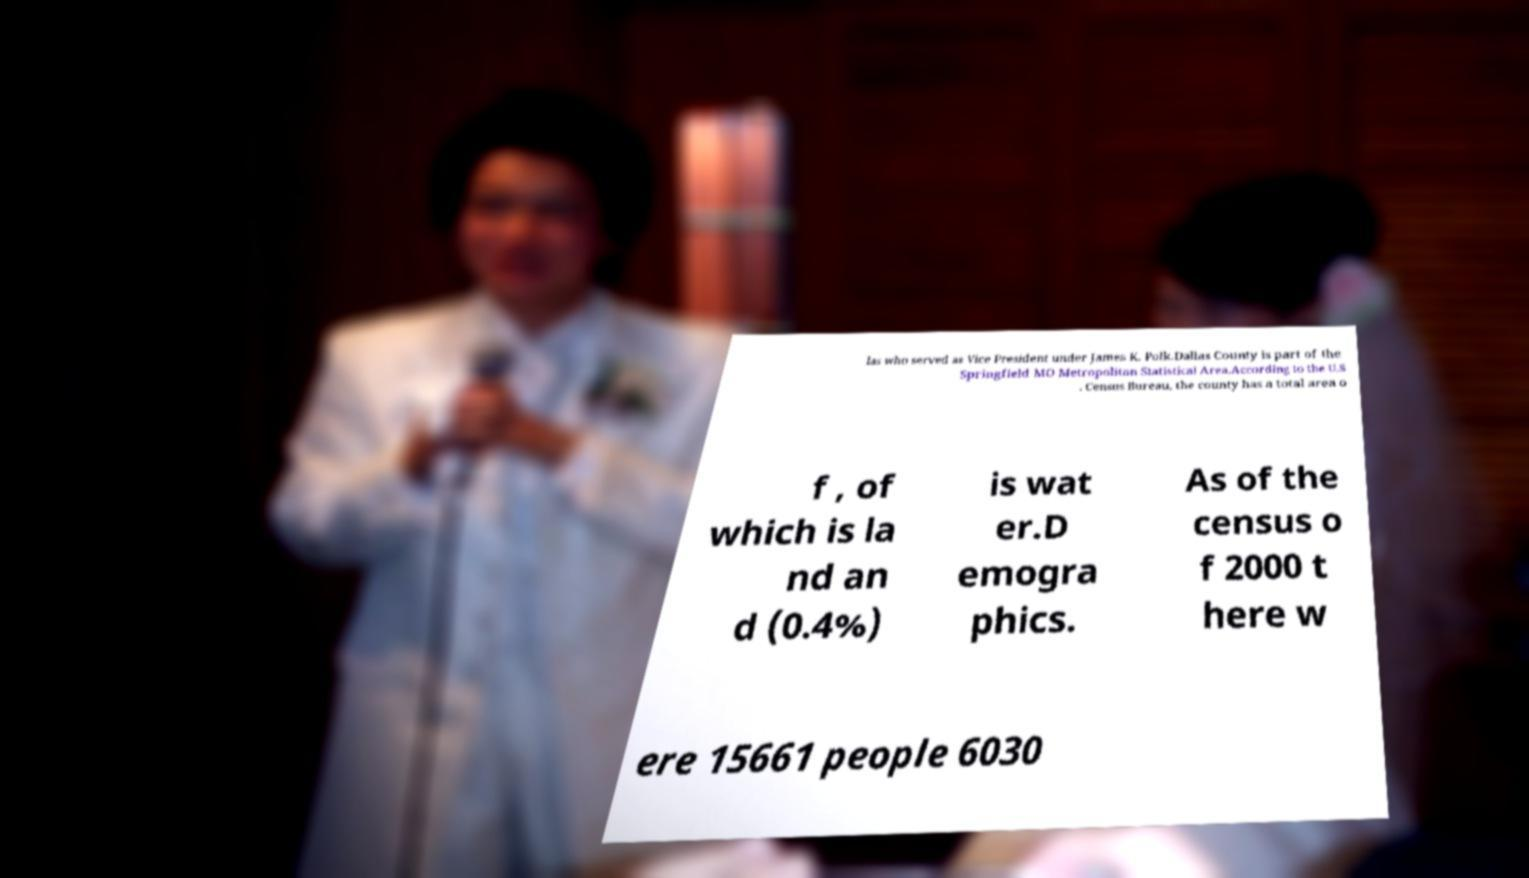Can you read and provide the text displayed in the image?This photo seems to have some interesting text. Can you extract and type it out for me? las who served as Vice President under James K. Polk.Dallas County is part of the Springfield MO Metropolitan Statistical Area.According to the U.S . Census Bureau, the county has a total area o f , of which is la nd an d (0.4%) is wat er.D emogra phics. As of the census o f 2000 t here w ere 15661 people 6030 